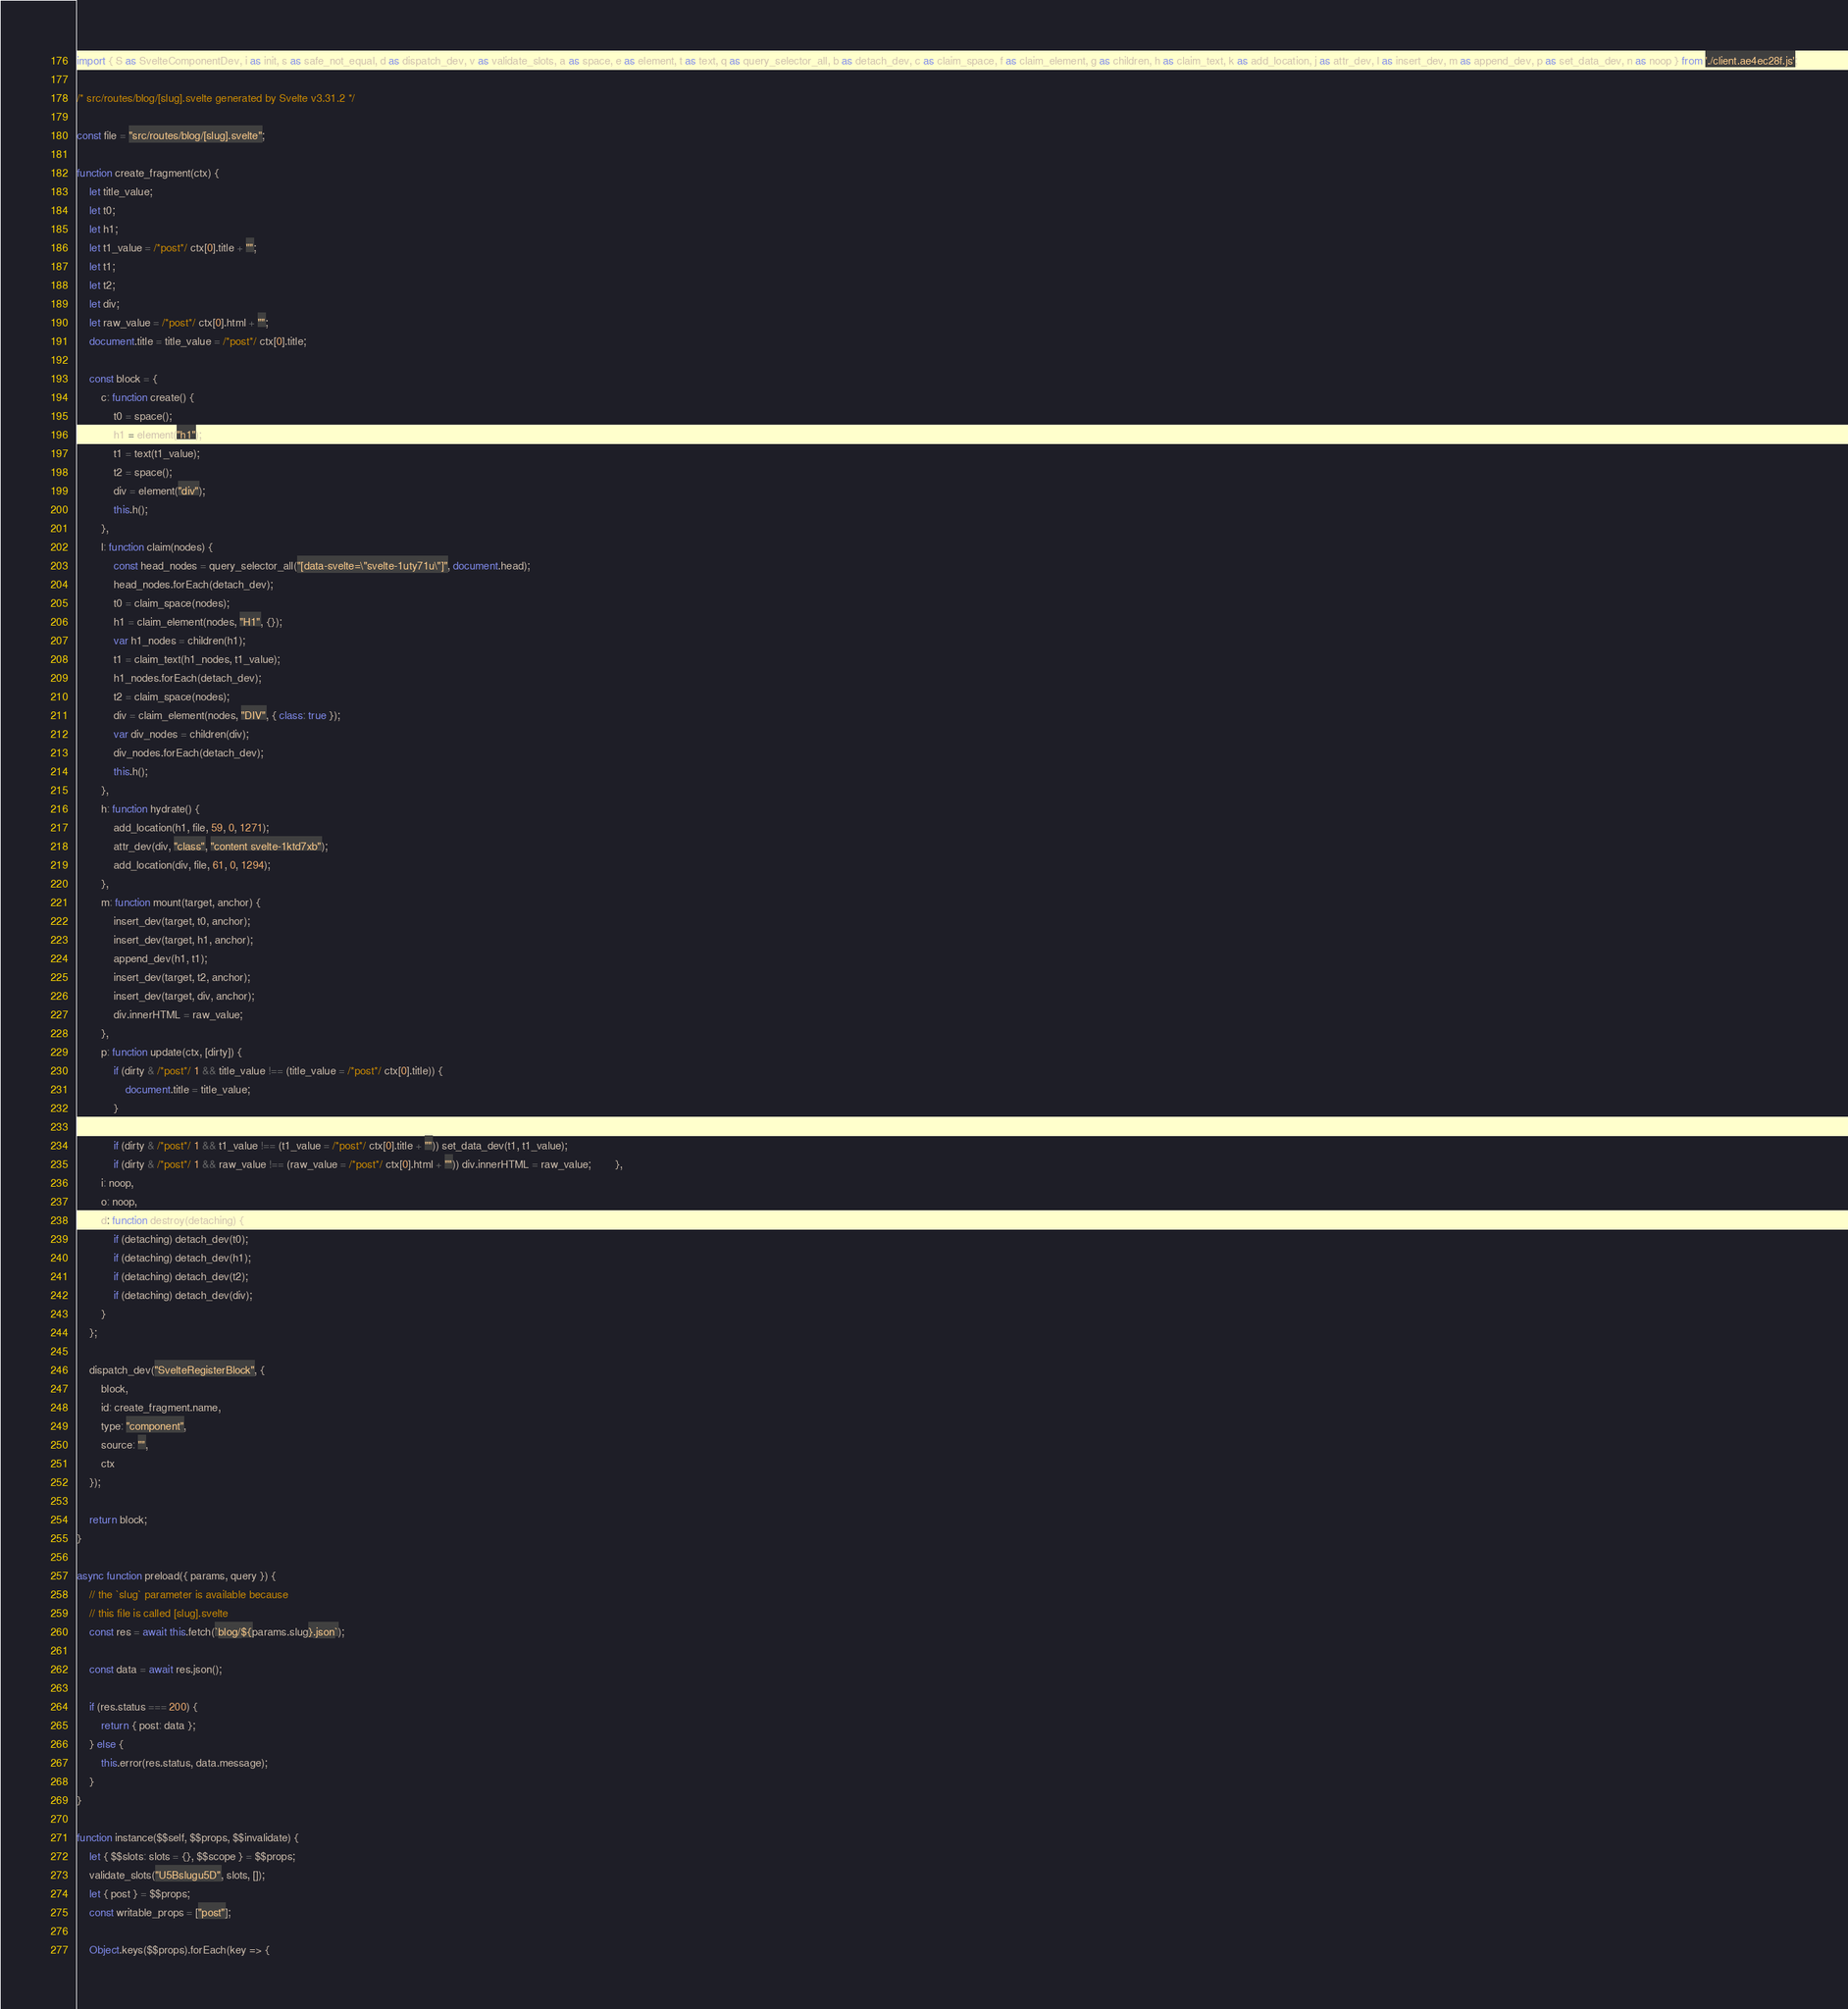Convert code to text. <code><loc_0><loc_0><loc_500><loc_500><_JavaScript_>import { S as SvelteComponentDev, i as init, s as safe_not_equal, d as dispatch_dev, v as validate_slots, a as space, e as element, t as text, q as query_selector_all, b as detach_dev, c as claim_space, f as claim_element, g as children, h as claim_text, k as add_location, j as attr_dev, l as insert_dev, m as append_dev, p as set_data_dev, n as noop } from './client.ae4ec28f.js';

/* src/routes/blog/[slug].svelte generated by Svelte v3.31.2 */

const file = "src/routes/blog/[slug].svelte";

function create_fragment(ctx) {
	let title_value;
	let t0;
	let h1;
	let t1_value = /*post*/ ctx[0].title + "";
	let t1;
	let t2;
	let div;
	let raw_value = /*post*/ ctx[0].html + "";
	document.title = title_value = /*post*/ ctx[0].title;

	const block = {
		c: function create() {
			t0 = space();
			h1 = element("h1");
			t1 = text(t1_value);
			t2 = space();
			div = element("div");
			this.h();
		},
		l: function claim(nodes) {
			const head_nodes = query_selector_all("[data-svelte=\"svelte-1uty71u\"]", document.head);
			head_nodes.forEach(detach_dev);
			t0 = claim_space(nodes);
			h1 = claim_element(nodes, "H1", {});
			var h1_nodes = children(h1);
			t1 = claim_text(h1_nodes, t1_value);
			h1_nodes.forEach(detach_dev);
			t2 = claim_space(nodes);
			div = claim_element(nodes, "DIV", { class: true });
			var div_nodes = children(div);
			div_nodes.forEach(detach_dev);
			this.h();
		},
		h: function hydrate() {
			add_location(h1, file, 59, 0, 1271);
			attr_dev(div, "class", "content svelte-1ktd7xb");
			add_location(div, file, 61, 0, 1294);
		},
		m: function mount(target, anchor) {
			insert_dev(target, t0, anchor);
			insert_dev(target, h1, anchor);
			append_dev(h1, t1);
			insert_dev(target, t2, anchor);
			insert_dev(target, div, anchor);
			div.innerHTML = raw_value;
		},
		p: function update(ctx, [dirty]) {
			if (dirty & /*post*/ 1 && title_value !== (title_value = /*post*/ ctx[0].title)) {
				document.title = title_value;
			}

			if (dirty & /*post*/ 1 && t1_value !== (t1_value = /*post*/ ctx[0].title + "")) set_data_dev(t1, t1_value);
			if (dirty & /*post*/ 1 && raw_value !== (raw_value = /*post*/ ctx[0].html + "")) div.innerHTML = raw_value;		},
		i: noop,
		o: noop,
		d: function destroy(detaching) {
			if (detaching) detach_dev(t0);
			if (detaching) detach_dev(h1);
			if (detaching) detach_dev(t2);
			if (detaching) detach_dev(div);
		}
	};

	dispatch_dev("SvelteRegisterBlock", {
		block,
		id: create_fragment.name,
		type: "component",
		source: "",
		ctx
	});

	return block;
}

async function preload({ params, query }) {
	// the `slug` parameter is available because
	// this file is called [slug].svelte
	const res = await this.fetch(`blog/${params.slug}.json`);

	const data = await res.json();

	if (res.status === 200) {
		return { post: data };
	} else {
		this.error(res.status, data.message);
	}
}

function instance($$self, $$props, $$invalidate) {
	let { $$slots: slots = {}, $$scope } = $$props;
	validate_slots("U5Bslugu5D", slots, []);
	let { post } = $$props;
	const writable_props = ["post"];

	Object.keys($$props).forEach(key => {</code> 